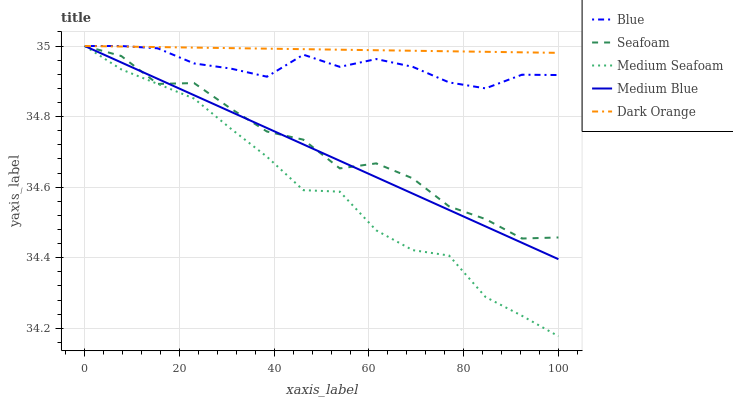Does Medium Seafoam have the minimum area under the curve?
Answer yes or no. Yes. Does Dark Orange have the maximum area under the curve?
Answer yes or no. Yes. Does Medium Blue have the minimum area under the curve?
Answer yes or no. No. Does Medium Blue have the maximum area under the curve?
Answer yes or no. No. Is Dark Orange the smoothest?
Answer yes or no. Yes. Is Seafoam the roughest?
Answer yes or no. Yes. Is Medium Blue the smoothest?
Answer yes or no. No. Is Medium Blue the roughest?
Answer yes or no. No. Does Medium Blue have the lowest value?
Answer yes or no. No. Does Medium Seafoam have the highest value?
Answer yes or no. Yes. Does Medium Blue intersect Medium Seafoam?
Answer yes or no. Yes. Is Medium Blue less than Medium Seafoam?
Answer yes or no. No. Is Medium Blue greater than Medium Seafoam?
Answer yes or no. No. 